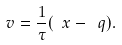<formula> <loc_0><loc_0><loc_500><loc_500>\ v = \frac { 1 } { \tau } ( \ x - \ q ) .</formula> 